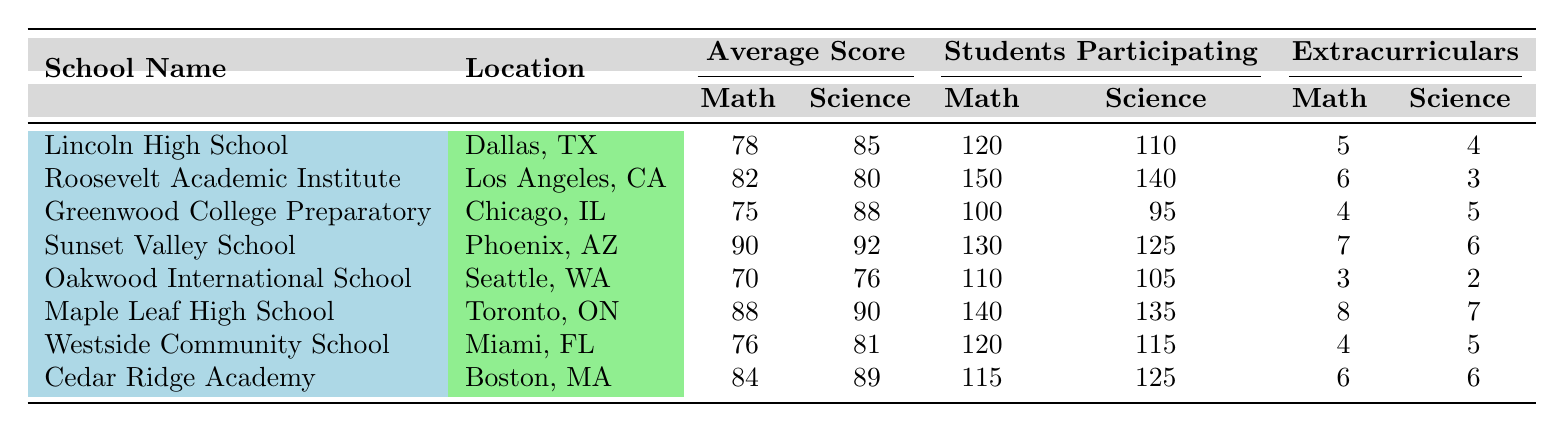What is the average math score of all schools? To find the average math score, add up all the math average scores: (78 + 82 + 75 + 90 + 70 + 88 + 76 + 84) =  543. Then divide by the number of schools, which is 8: 543 / 8 = 67.875.
Answer: 67.875 Which school has the highest science average score? The science average scores are as follows: Lincoln High School (85), Roosevelt Academic Institute (80), Greenwood College Preparatory (88), Sunset Valley School (92), Oakwood International School (76), Maple Leaf High School (90), Westside Community School (81), and Cedar Ridge Academy (89). The highest score is 92 from Sunset Valley School.
Answer: Sunset Valley School Did Lincoln High School have more students participate in math or science? Lincoln High School had 120 students participating in math and 110 students participating in science. Since 120 (math) is greater than 110 (science), the answer is math.
Answer: Math What is the difference in average math scores between the highest and lowest scoring schools? The highest average math score is from Sunset Valley School (90) and the lowest is from Oakwood International School (70). The difference is calculated as 90 - 70 = 20.
Answer: 20 Which school had the highest number of students participating in math and what was that number? The participating math students are: Lincoln High School (120), Roosevelt Academic Institute (150), Greenwood College Preparatory (100), Sunset Valley School (130), Oakwood International School (110), Maple Leaf High School (140), Westside Community School (120), and Cedar Ridge Academy (115). The highest number is 150 from Roosevelt Academic Institute.
Answer: 150 How many extracurricular activities related to math does Maple Leaf High School offer compared to Oakwood International School? Maple Leaf High School offers 8 math extracurriculars and Oakwood International School offers 3. The difference is 8 - 3 = 5, indicating Maple Leaf offers more.
Answer: 5 more Is there a school where students participated in both math and science activities that is greater than 130? If we analyze the schools, Sunset Valley School (130 math) and Maple Leaf High School (140 math). The only one exceeding 130 for both is Maple Leaf High School (math: 140, science: 135).
Answer: Yes, Maple Leaf High School Calculate the average number of extracurricular activities related to science across all the schools. The total number of science extracurriculars for each school is: 4 (Lincoln) + 3 (Roosevelt) + 5 (Greenwood) + 6 (Sunset) + 2 (Oakwood) + 7 (Maple Leaf) + 5 (Westside) + 6 (Cedar Ridge) = 38. Then, dividing by 8 schools we get 38 / 8 = 4.75.
Answer: 4.75 